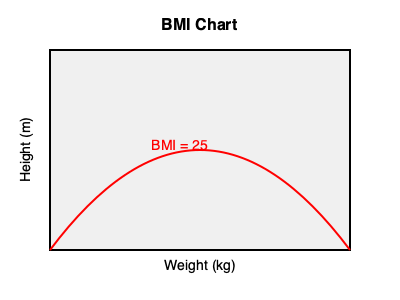During a family conversation, you learn that your cousin, who is 1.75 meters tall and weighs 78 kilograms, is concerned about their weight. As a physiotherapist working at your local sports club, you decide to calculate their Body Mass Index (BMI) to provide professional advice. Using the formula BMI = weight (kg) / height² (m²), determine your cousin's BMI and interpret the result based on the standard BMI categories: Underweight (< 18.5), Normal weight (18.5 - 24.9), Overweight (25 - 29.9), and Obese (≥ 30). To calculate the BMI, we'll follow these steps:

1. Identify the given information:
   - Height (h) = 1.75 m
   - Weight (w) = 78 kg

2. Apply the BMI formula:
   BMI = weight (kg) / height² (m²)

3. Calculate the height squared:
   h² = 1.75 m × 1.75 m = 3.0625 m²

4. Divide the weight by the height squared:
   BMI = 78 kg / 3.0625 m²
   BMI ≈ 25.47 kg/m²

5. Interpret the result:
   A BMI of 25.47 falls into the "Overweight" category (25 - 29.9).

As a physiotherapist, you can use this information to provide tailored advice to your cousin about maintaining a healthy weight through proper exercise and nutrition, which you can implement in your local sports club work.
Answer: BMI ≈ 25.47 kg/m² (Overweight) 